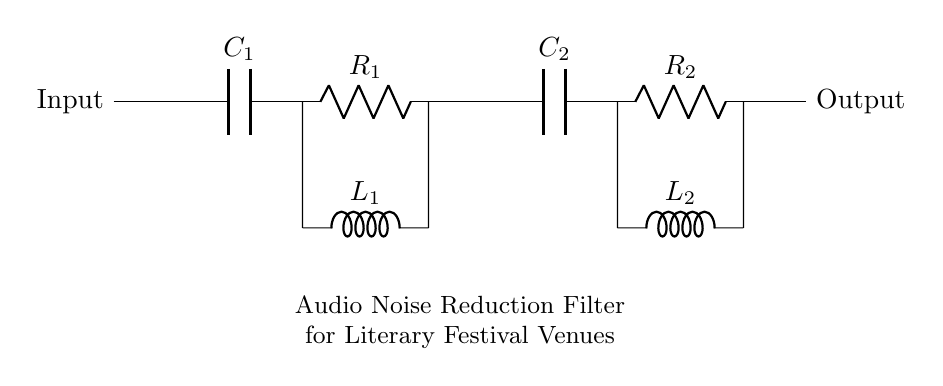What type of filter is presented in this circuit? The circuit represents an audio noise reduction filter, which is indicated in the labeling provided below the circuit diagram.
Answer: Audio noise reduction filter What is the role of the capacitors in this circuit? Capacitors (C1 and C2) in this filter circuit are used to block direct current while allowing alternating current signals (audio) to pass through, aiding in noise reduction by filtering unwanted frequencies.
Answer: Blocking DC What components are used in the circuit? The components include two capacitors (C1 and C2), two resistors (R1 and R2), and two inductors (L1 and L2), as observed from the labels alongside each component in the diagram.
Answer: C1, C2, R1, R2, L1, L2 What is the purpose of the resistors in this filter? Resistors (R1 and R2) help to dissipate energy and control the signal levels running through the circuit, stabilizing the filter performance by providing damping and affecting the frequency response.
Answer: Control signal levels How do the inductors impact the circuit performance? Inductors (L1 and L2) are used to store energy in a magnetic field, which contributes to the filtering process by defining the frequency characteristics and helping to reduce noise by attenuating higher frequencies.
Answer: Attenuate high frequencies What is the configuration of the components in the circuit? The configuration in this audio filter circuit is a combination of capacitors, resistors, and inductors arranged in series and parallel, forming a low-pass filter characteristic that allows desired audio signals to pass while reducing noise.
Answer: Series and parallel 